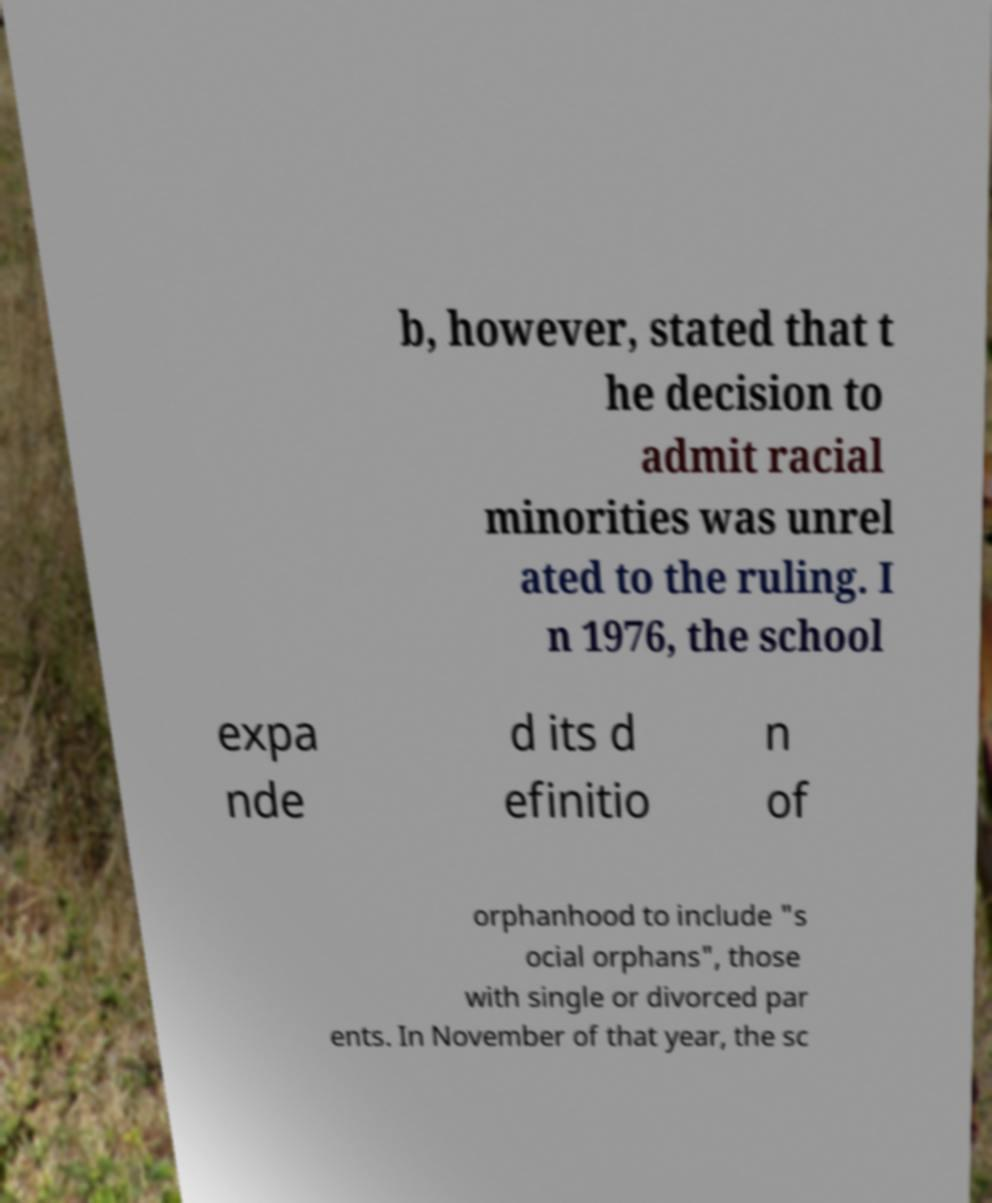Please identify and transcribe the text found in this image. b, however, stated that t he decision to admit racial minorities was unrel ated to the ruling. I n 1976, the school expa nde d its d efinitio n of orphanhood to include "s ocial orphans", those with single or divorced par ents. In November of that year, the sc 